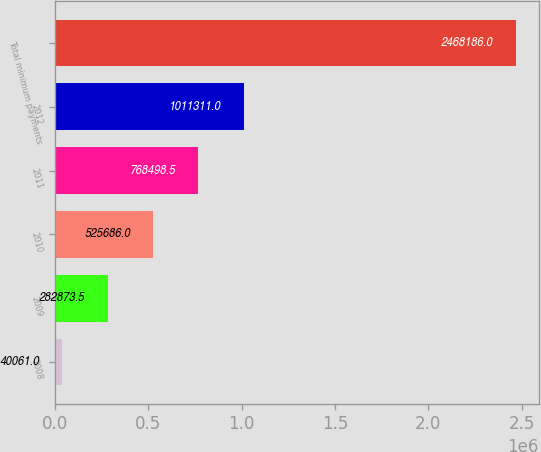Convert chart. <chart><loc_0><loc_0><loc_500><loc_500><bar_chart><fcel>2008<fcel>2009<fcel>2010<fcel>2011<fcel>2012<fcel>Total minimum payments<nl><fcel>40061<fcel>282874<fcel>525686<fcel>768498<fcel>1.01131e+06<fcel>2.46819e+06<nl></chart> 